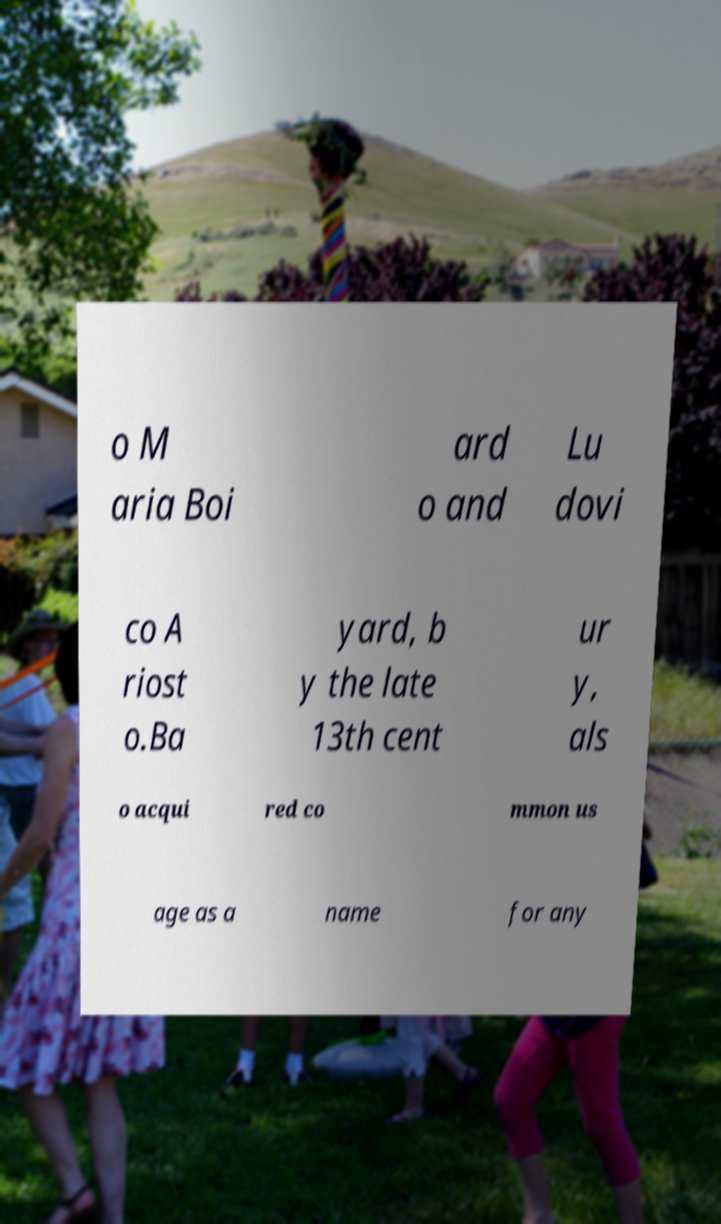For documentation purposes, I need the text within this image transcribed. Could you provide that? o M aria Boi ard o and Lu dovi co A riost o.Ba yard, b y the late 13th cent ur y, als o acqui red co mmon us age as a name for any 